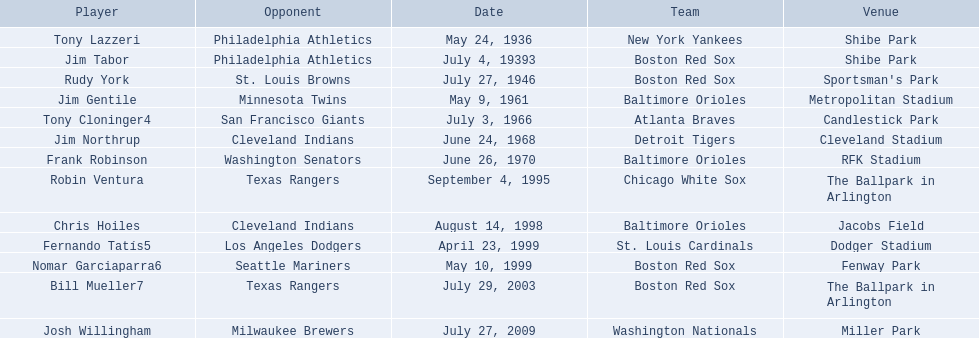Who are all the opponents? Philadelphia Athletics, Philadelphia Athletics, St. Louis Browns, Minnesota Twins, San Francisco Giants, Cleveland Indians, Washington Senators, Texas Rangers, Cleveland Indians, Los Angeles Dodgers, Seattle Mariners, Texas Rangers, Milwaukee Brewers. What teams played on july 27, 1946? Boston Red Sox, July 27, 1946, St. Louis Browns. Who was the opponent in this game? St. Louis Browns. 